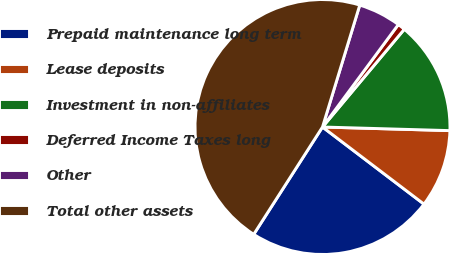Convert chart. <chart><loc_0><loc_0><loc_500><loc_500><pie_chart><fcel>Prepaid maintenance long term<fcel>Lease deposits<fcel>Investment in non-affiliates<fcel>Deferred Income Taxes long<fcel>Other<fcel>Total other assets<nl><fcel>23.73%<fcel>9.89%<fcel>14.36%<fcel>0.95%<fcel>5.42%<fcel>45.65%<nl></chart> 